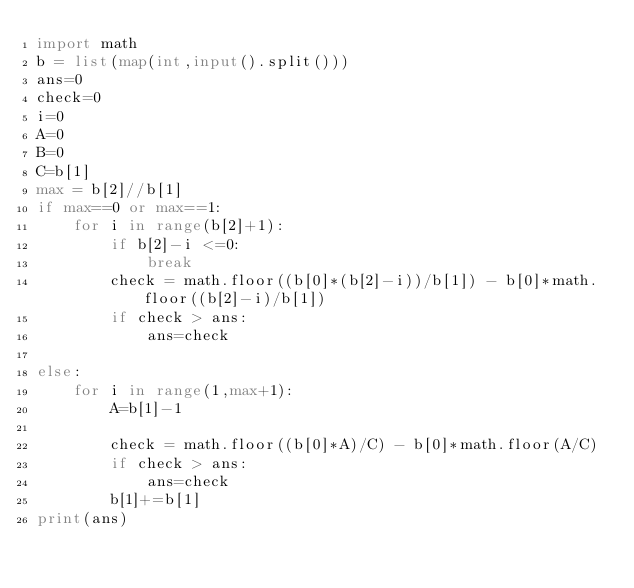<code> <loc_0><loc_0><loc_500><loc_500><_Python_>import math
b = list(map(int,input().split()))
ans=0
check=0
i=0
A=0
B=0
C=b[1]
max = b[2]//b[1]
if max==0 or max==1:
    for i in range(b[2]+1):
        if b[2]-i <=0:
            break
        check = math.floor((b[0]*(b[2]-i))/b[1]) - b[0]*math.floor((b[2]-i)/b[1])
        if check > ans:
            ans=check

else:
    for i in range(1,max+1):
        A=b[1]-1
        
        check = math.floor((b[0]*A)/C) - b[0]*math.floor(A/C)
        if check > ans:
            ans=check
        b[1]+=b[1]
print(ans)</code> 